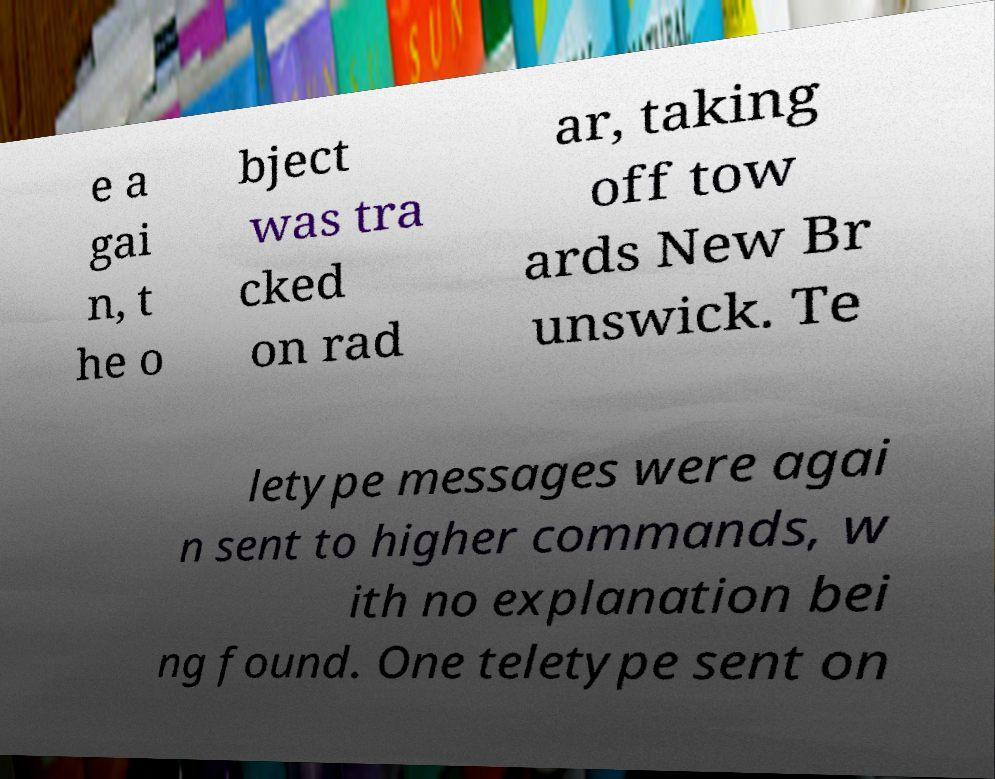Can you read and provide the text displayed in the image?This photo seems to have some interesting text. Can you extract and type it out for me? e a gai n, t he o bject was tra cked on rad ar, taking off tow ards New Br unswick. Te letype messages were agai n sent to higher commands, w ith no explanation bei ng found. One teletype sent on 